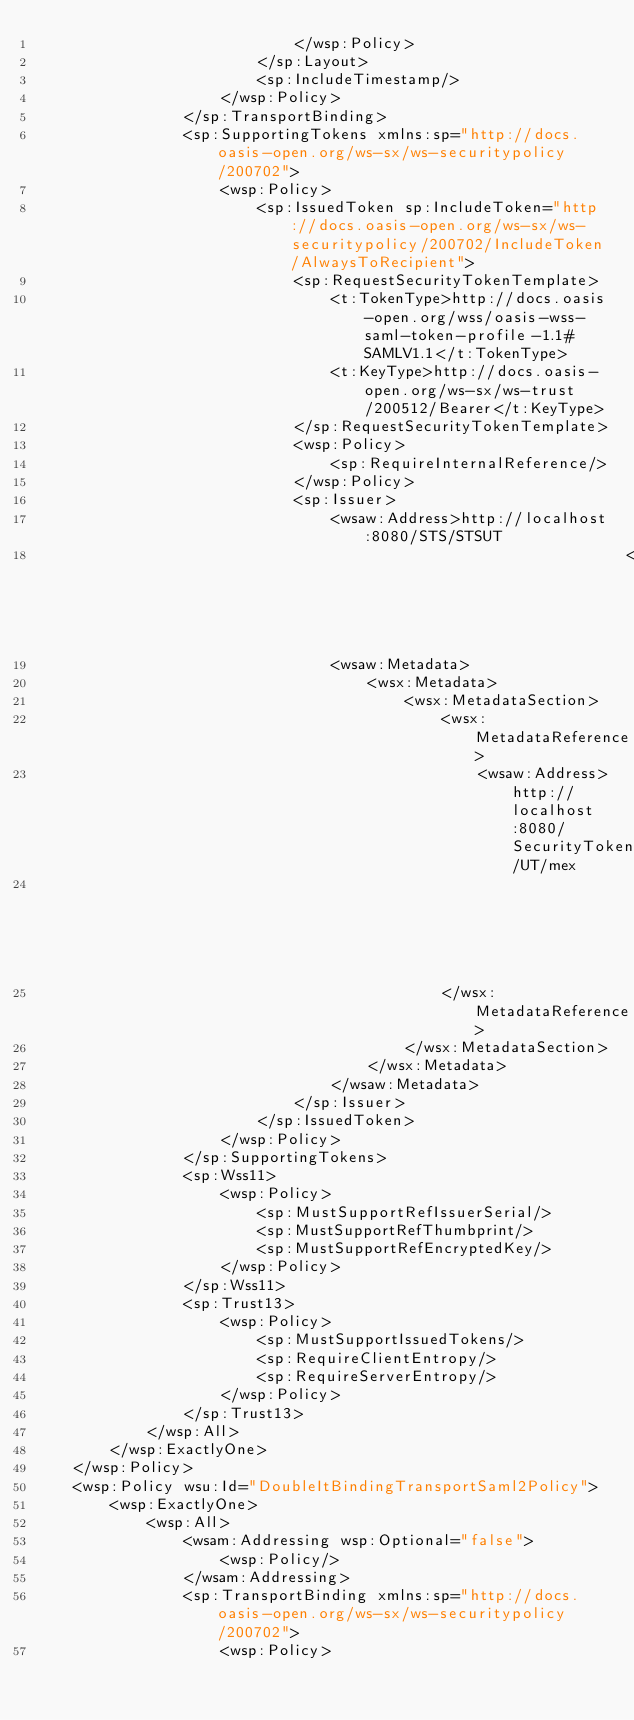Convert code to text. <code><loc_0><loc_0><loc_500><loc_500><_XML_>                            </wsp:Policy>
                        </sp:Layout>
                        <sp:IncludeTimestamp/>
                    </wsp:Policy>
                </sp:TransportBinding>
                <sp:SupportingTokens xmlns:sp="http://docs.oasis-open.org/ws-sx/ws-securitypolicy/200702">
                    <wsp:Policy>
                        <sp:IssuedToken sp:IncludeToken="http://docs.oasis-open.org/ws-sx/ws-securitypolicy/200702/IncludeToken/AlwaysToRecipient">
                            <sp:RequestSecurityTokenTemplate>
                                <t:TokenType>http://docs.oasis-open.org/wss/oasis-wss-saml-token-profile-1.1#SAMLV1.1</t:TokenType>
                                <t:KeyType>http://docs.oasis-open.org/ws-sx/ws-trust/200512/Bearer</t:KeyType>
                            </sp:RequestSecurityTokenTemplate>
                            <wsp:Policy>
                                <sp:RequireInternalReference/>
                            </wsp:Policy>
                            <sp:Issuer>
                                <wsaw:Address>http://localhost:8080/STS/STSUT
                                                                </wsaw:Address>
                                <wsaw:Metadata>
                                    <wsx:Metadata>
                                        <wsx:MetadataSection>
                                            <wsx:MetadataReference>
                                                <wsaw:Address>http://localhost:8080/SecurityTokenService/UT/mex
                                                                                                </wsaw:Address>
                                            </wsx:MetadataReference>
                                        </wsx:MetadataSection>
                                    </wsx:Metadata>
                                </wsaw:Metadata>
                            </sp:Issuer>
                        </sp:IssuedToken>
                    </wsp:Policy>
                </sp:SupportingTokens>
                <sp:Wss11>
                    <wsp:Policy>
                        <sp:MustSupportRefIssuerSerial/>
                        <sp:MustSupportRefThumbprint/>
                        <sp:MustSupportRefEncryptedKey/>
                    </wsp:Policy>
                </sp:Wss11>
                <sp:Trust13>
                    <wsp:Policy>
                        <sp:MustSupportIssuedTokens/>
                        <sp:RequireClientEntropy/>
                        <sp:RequireServerEntropy/>
                    </wsp:Policy>
                </sp:Trust13>
            </wsp:All>
        </wsp:ExactlyOne>
    </wsp:Policy>
    <wsp:Policy wsu:Id="DoubleItBindingTransportSaml2Policy">
        <wsp:ExactlyOne>
            <wsp:All>
                <wsam:Addressing wsp:Optional="false">
                    <wsp:Policy/>
                </wsam:Addressing>
                <sp:TransportBinding xmlns:sp="http://docs.oasis-open.org/ws-sx/ws-securitypolicy/200702">
                    <wsp:Policy></code> 